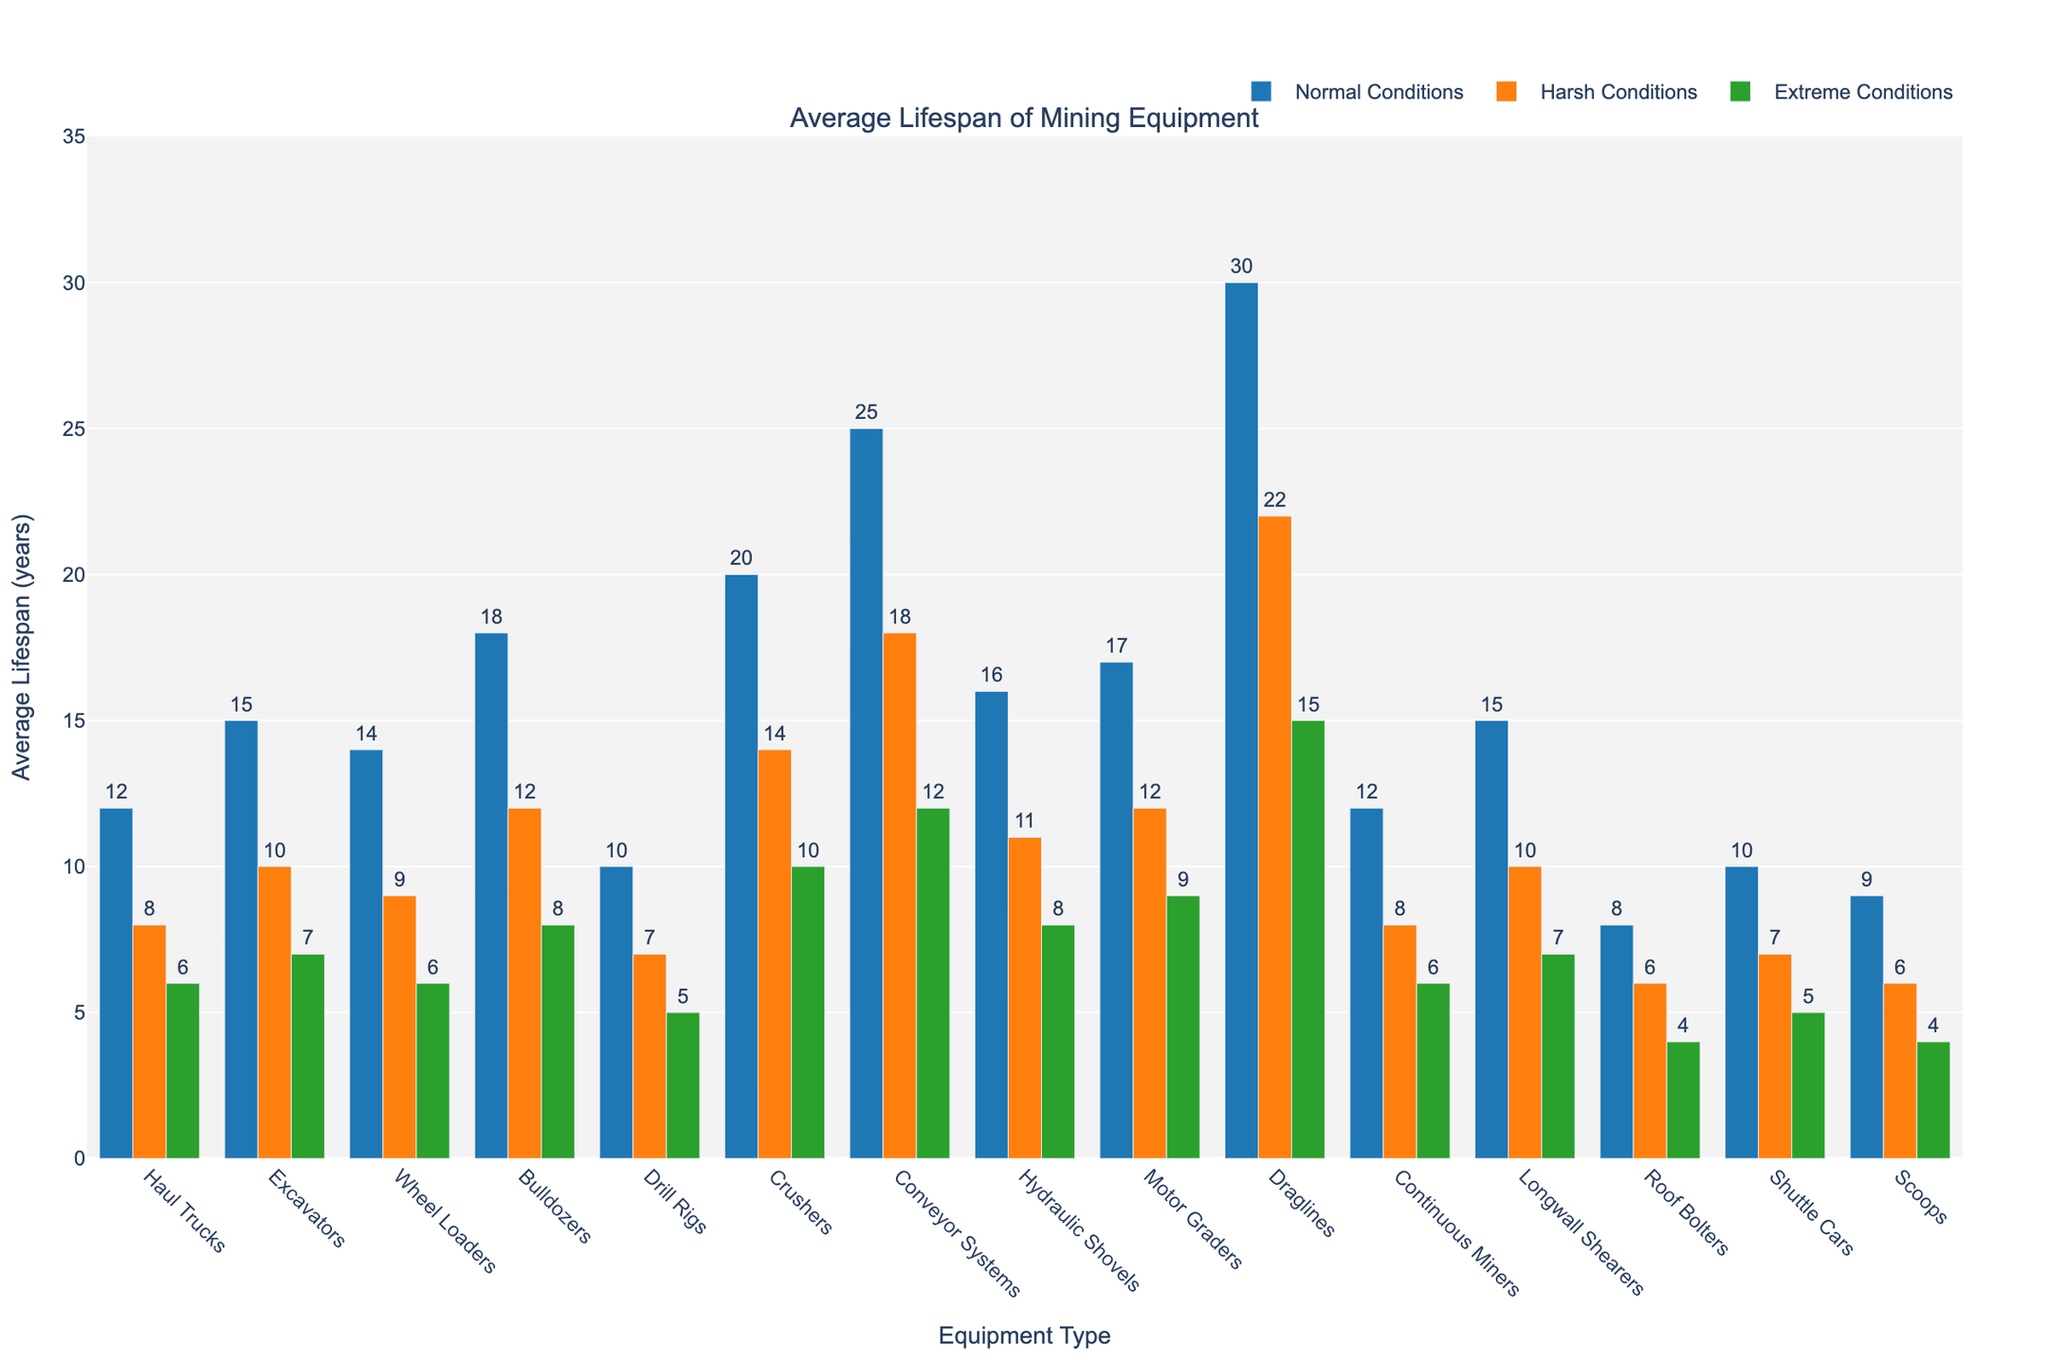Which equipment has the longest lifespan under normal conditions? The bar labeled "Draglines" has the tallest height under the "Normal Conditions (years)" category, indicating the longest lifespan under normal conditions.
Answer: Draglines How much longer is the lifespan of Crushers under harsh conditions compared to extreme conditions? The height of the "Crushers" bar for "Harsh Conditions (years)" is 14 and for "Extreme Conditions (years)" it is 10. Calculating the difference: 14 - 10.
Answer: 4 years What is the average lifespan of Haul Trucks, Excavators, and Wheel Loaders under extreme conditions? Sum the lifespan of Haul Trucks, Excavators, and Wheel Loaders under extreme conditions: 6 + 7 + 6 = 19. Then divide by 3 to find the average: 19/3.
Answer: 6.33 years Which equipment shows the smallest decrease in lifespan from normal to extreme conditions? Calculate the decrease for each equipment from normal to extreme conditions. The smallest decrease is seen in Roof Bolters: 8 - 4 = 4.
Answer: Roof Bolters Is the lifespan of Hydraulic Shovels under normal conditions greater than Motor Graders under harsh conditions? Compare the height of the "Hydraulic Shovels" bar under normal conditions (16) to the height of the "Motor Graders" bar under harsh conditions (12).
Answer: Yes Which equipment categories have identical lifespans under harsh and extreme conditions? Identify equipment where the bar heights for harsh and extreme conditions are equal. Both "Haul Trucks" and "Continuous Miners" have lifespans of 8 years under harsh conditions and 6 years under extreme conditions.
Answer: Haul Trucks, Continuous Miners By how many years does the lifespan of Conveyor Systems decrease when moving from normal to extreme conditions? Subtract the height of the "Conveyor Systems" bar under extreme conditions (12) from the height under normal conditions (25): 25 - 12.
Answer: 13 years What is the total lifespan of Roof Bolters under all three operating conditions? Add the heights of the "Roof Bolters" bars under normal (8), harsh (6), and extreme (4) conditions: 8 + 6 + 4.
Answer: 18 years Which condition shows the highest average lifespan across all equipment categories? Calculate the average lifespan for each condition and compare: Normal Conditions (average ~15.23), Harsh Conditions (average ~10.54), Extreme Conditions (average ~7.31).
Answer: Normal Conditions 